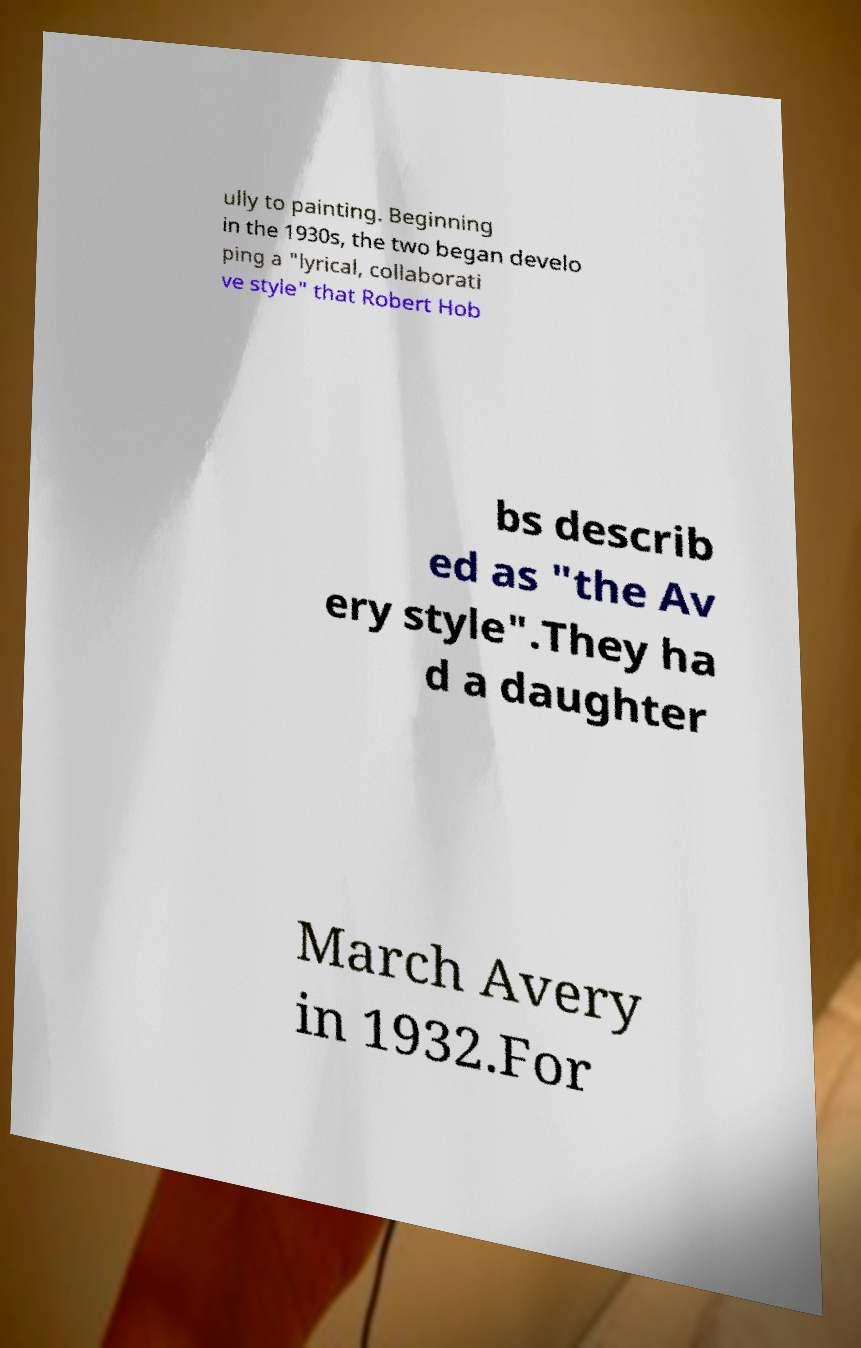Can you read and provide the text displayed in the image?This photo seems to have some interesting text. Can you extract and type it out for me? ully to painting. Beginning in the 1930s, the two began develo ping a "lyrical, collaborati ve style" that Robert Hob bs describ ed as "the Av ery style".They ha d a daughter March Avery in 1932.For 